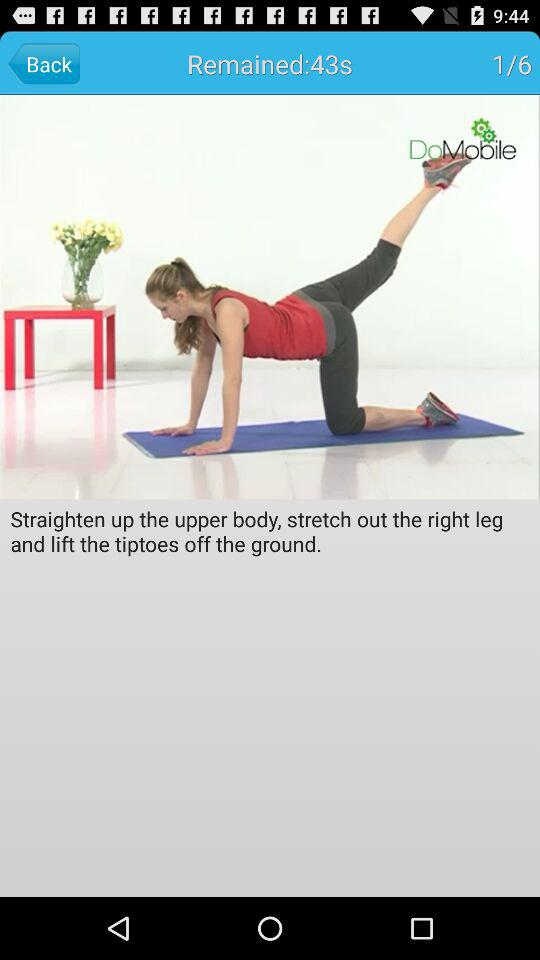How much time is left? There are 43 seconds left. 